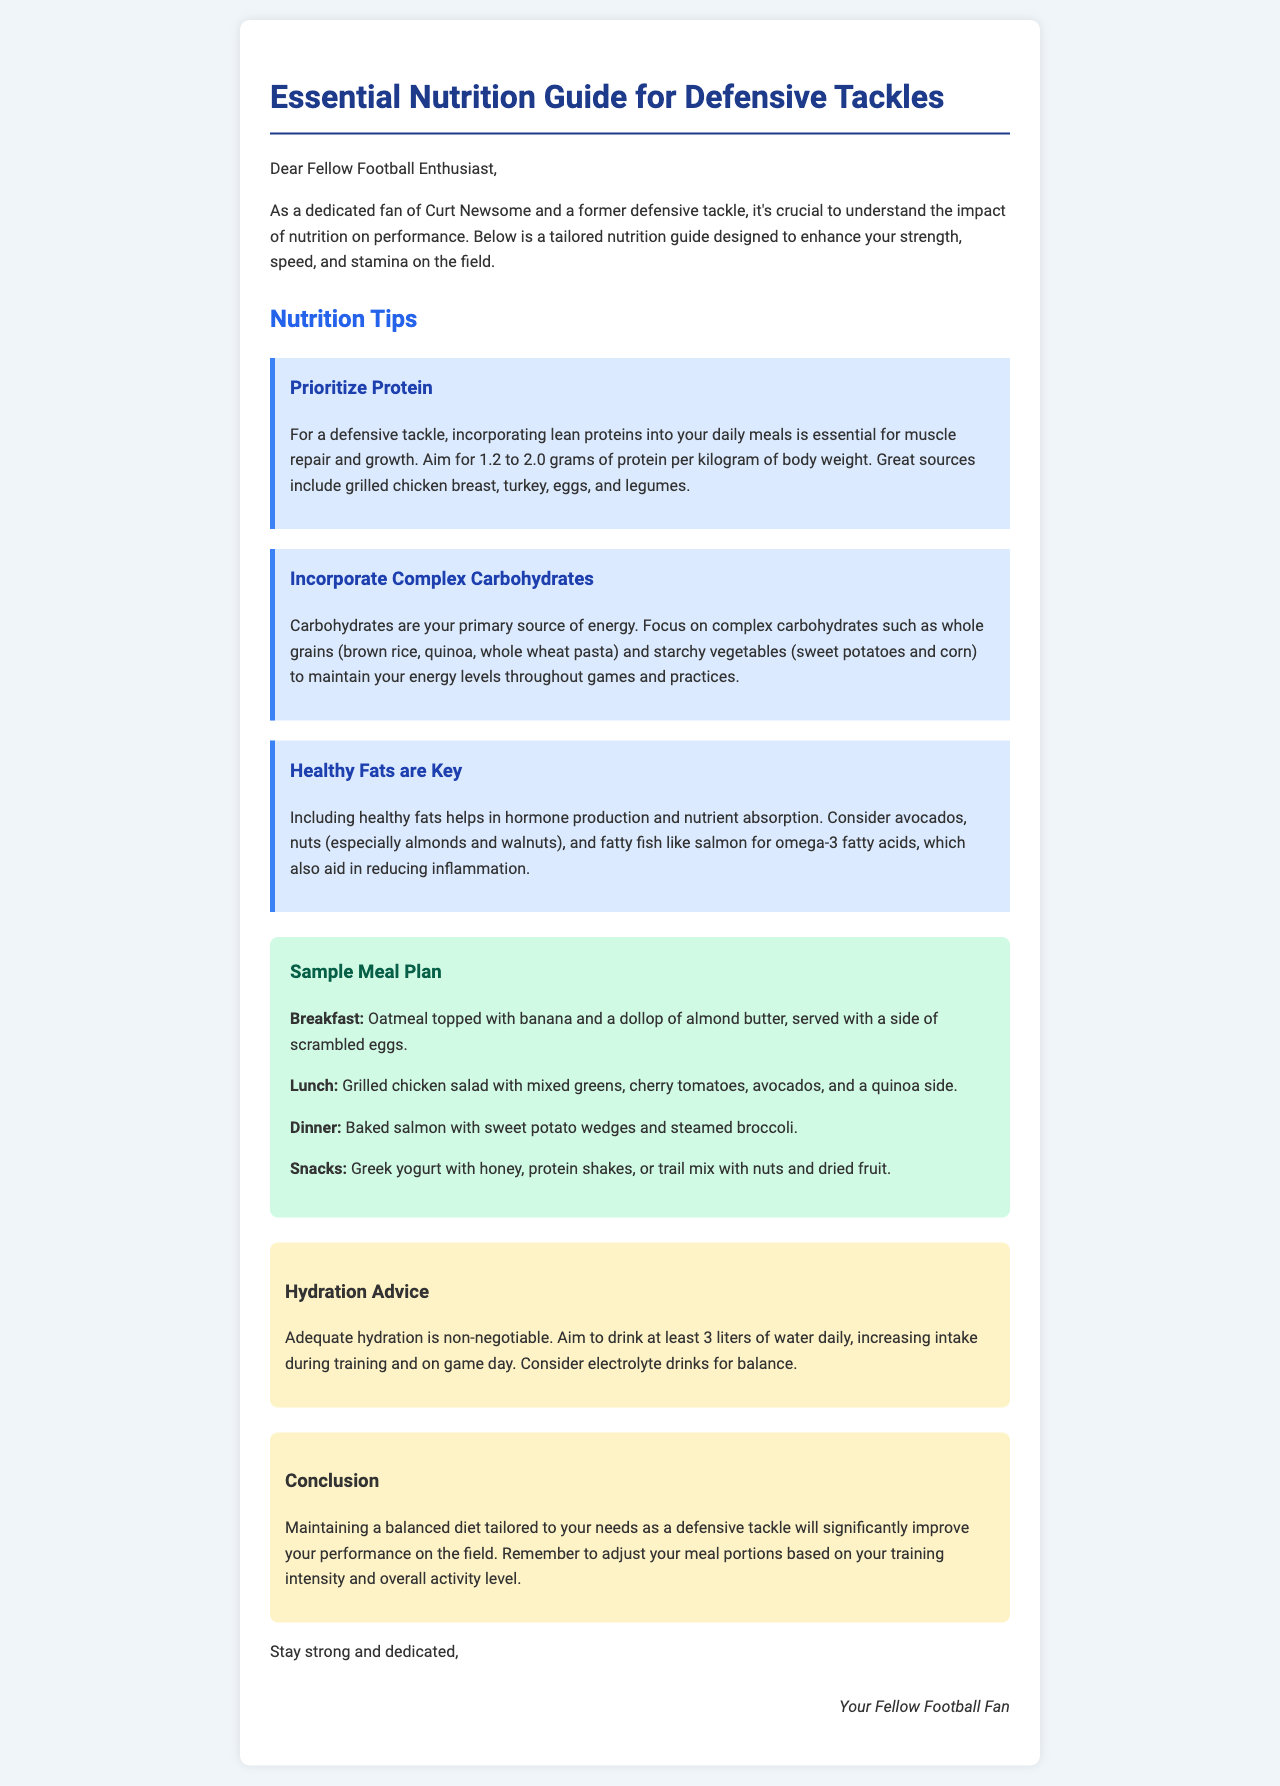What is the target protein intake range? The protein intake should aim for 1.2 to 2.0 grams per kilogram of body weight, as stated in the nutrition tips.
Answer: 1.2 to 2.0 grams What is a great source of lean protein? The document mentions several sources of lean protein, including grilled chicken breast, turkey, eggs, and legumes.
Answer: Grilled chicken breast What type of carbohydrates should defensive tackles focus on? The guide emphasizes the importance of complex carbohydrates such as whole grains and starchy vegetables.
Answer: Complex carbohydrates What is included in the sample breakfast? The sample breakfast consists of oatmeal topped with banana and almond butter, served with scrambled eggs.
Answer: Oatmeal topped with banana and almond butter, scrambled eggs What is the daily water intake recommendation? The hydration advice section states that athletes should aim to drink at least 3 liters of water daily.
Answer: 3 liters What is the purpose of healthy fats according to the document? The document specifies that healthy fats help in hormone production and nutrient absorption.
Answer: Hormone production and nutrient absorption Which meal plan includes quinoa? The lunch in the meal plan consists of grilled chicken salad with mixed greens, cherry tomatoes, avocados, and a quinoa side.
Answer: Lunch What should you consider increasing on game day? The hydration advice suggests considering increasing electrolyte drinks for balance during training and game day.
Answer: Electrolyte drinks 